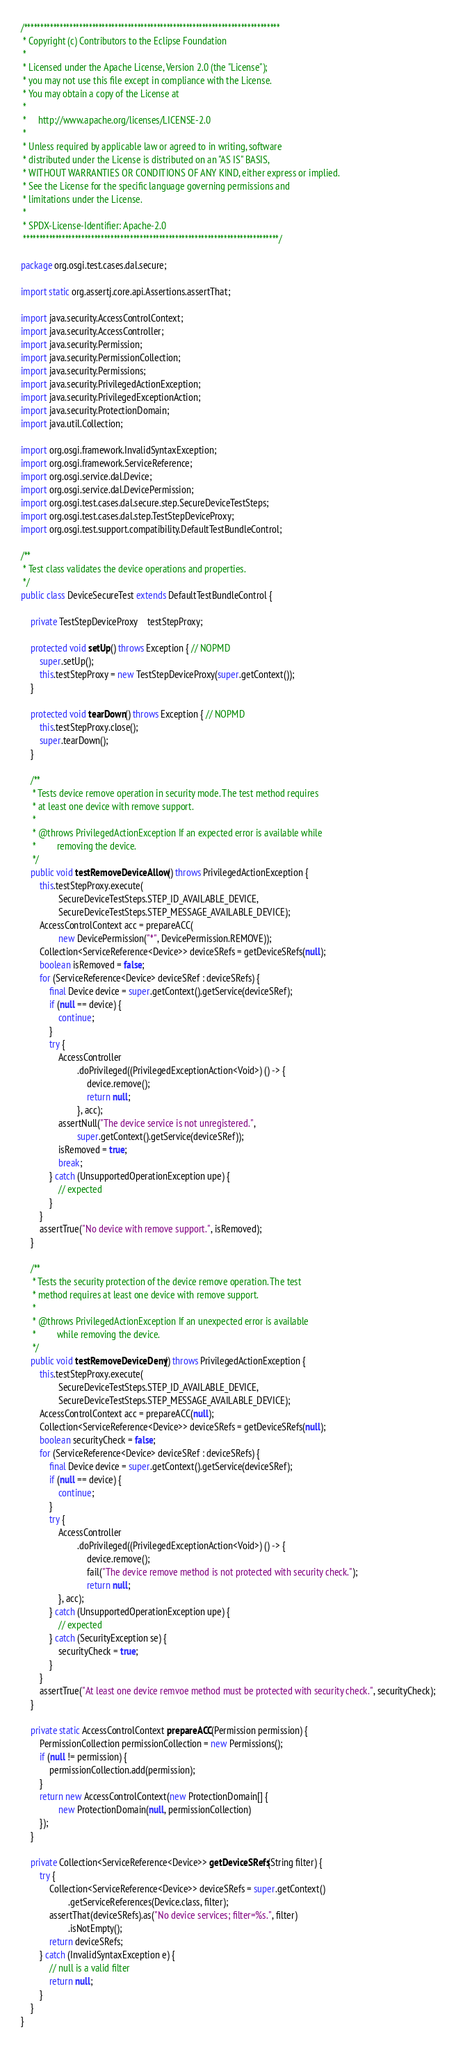Convert code to text. <code><loc_0><loc_0><loc_500><loc_500><_Java_>/*******************************************************************************
 * Copyright (c) Contributors to the Eclipse Foundation
 *
 * Licensed under the Apache License, Version 2.0 (the "License");
 * you may not use this file except in compliance with the License.
 * You may obtain a copy of the License at
 *
 *     http://www.apache.org/licenses/LICENSE-2.0
 *
 * Unless required by applicable law or agreed to in writing, software
 * distributed under the License is distributed on an "AS IS" BASIS,
 * WITHOUT WARRANTIES OR CONDITIONS OF ANY KIND, either express or implied.
 * See the License for the specific language governing permissions and
 * limitations under the License.
 *
 * SPDX-License-Identifier: Apache-2.0 
 *******************************************************************************/

package org.osgi.test.cases.dal.secure;

import static org.assertj.core.api.Assertions.assertThat;

import java.security.AccessControlContext;
import java.security.AccessController;
import java.security.Permission;
import java.security.PermissionCollection;
import java.security.Permissions;
import java.security.PrivilegedActionException;
import java.security.PrivilegedExceptionAction;
import java.security.ProtectionDomain;
import java.util.Collection;

import org.osgi.framework.InvalidSyntaxException;
import org.osgi.framework.ServiceReference;
import org.osgi.service.dal.Device;
import org.osgi.service.dal.DevicePermission;
import org.osgi.test.cases.dal.secure.step.SecureDeviceTestSteps;
import org.osgi.test.cases.dal.step.TestStepDeviceProxy;
import org.osgi.test.support.compatibility.DefaultTestBundleControl;

/**
 * Test class validates the device operations and properties.
 */
public class DeviceSecureTest extends DefaultTestBundleControl {

	private TestStepDeviceProxy	testStepProxy;

	protected void setUp() throws Exception { // NOPMD
		super.setUp();
		this.testStepProxy = new TestStepDeviceProxy(super.getContext());
	}

	protected void tearDown() throws Exception { // NOPMD
		this.testStepProxy.close();
		super.tearDown();
	}

	/**
	 * Tests device remove operation in security mode. The test method requires
	 * at least one device with remove support.
	 * 
	 * @throws PrivilegedActionException If an expected error is available while
	 *         removing the device.
	 */
	public void testRemoveDeviceAllow() throws PrivilegedActionException {
		this.testStepProxy.execute(
				SecureDeviceTestSteps.STEP_ID_AVAILABLE_DEVICE,
				SecureDeviceTestSteps.STEP_MESSAGE_AVAILABLE_DEVICE);
		AccessControlContext acc = prepareACC(
				new DevicePermission("*", DevicePermission.REMOVE));
		Collection<ServiceReference<Device>> deviceSRefs = getDeviceSRefs(null);
		boolean isRemoved = false;
		for (ServiceReference<Device> deviceSRef : deviceSRefs) {
			final Device device = super.getContext().getService(deviceSRef);
			if (null == device) {
				continue;
			}
			try {
				AccessController
						.doPrivileged((PrivilegedExceptionAction<Void>) () -> {
							device.remove();
							return null;
						}, acc);
				assertNull("The device service is not unregistered.",
						super.getContext().getService(deviceSRef));
				isRemoved = true;
				break;
			} catch (UnsupportedOperationException upe) {
				// expected
			}
		}
		assertTrue("No device with remove support.", isRemoved);
	}

	/**
	 * Tests the security protection of the device remove operation. The test
	 * method requires at least one device with remove support.
	 * 
	 * @throws PrivilegedActionException If an unexpected error is available
	 *         while removing the device.
	 */
	public void testRemoveDeviceDeny() throws PrivilegedActionException {
		this.testStepProxy.execute(
				SecureDeviceTestSteps.STEP_ID_AVAILABLE_DEVICE,
				SecureDeviceTestSteps.STEP_MESSAGE_AVAILABLE_DEVICE);
		AccessControlContext acc = prepareACC(null);
		Collection<ServiceReference<Device>> deviceSRefs = getDeviceSRefs(null);
		boolean securityCheck = false;
		for (ServiceReference<Device> deviceSRef : deviceSRefs) {
			final Device device = super.getContext().getService(deviceSRef);
			if (null == device) {
				continue;
			}
			try {
				AccessController
						.doPrivileged((PrivilegedExceptionAction<Void>) () -> {
							device.remove();
							fail("The device remove method is not protected with security check.");
							return null;
				}, acc);
			} catch (UnsupportedOperationException upe) {
				// expected
			} catch (SecurityException se) {
				securityCheck = true;
			}
		}
		assertTrue("At least one device remvoe method must be protected with security check.", securityCheck);
	}

	private static AccessControlContext prepareACC(Permission permission) {
		PermissionCollection permissionCollection = new Permissions();
		if (null != permission) {
			permissionCollection.add(permission);
		}
		return new AccessControlContext(new ProtectionDomain[] {
				new ProtectionDomain(null, permissionCollection)
		});
	}

	private Collection<ServiceReference<Device>> getDeviceSRefs(String filter) {
		try {
			Collection<ServiceReference<Device>> deviceSRefs = super.getContext()
					.getServiceReferences(Device.class, filter);
			assertThat(deviceSRefs).as("No device services; filter=%s.", filter)
					.isNotEmpty();
			return deviceSRefs;
		} catch (InvalidSyntaxException e) {
			// null is a valid filter
			return null;
		}
	}
}
</code> 